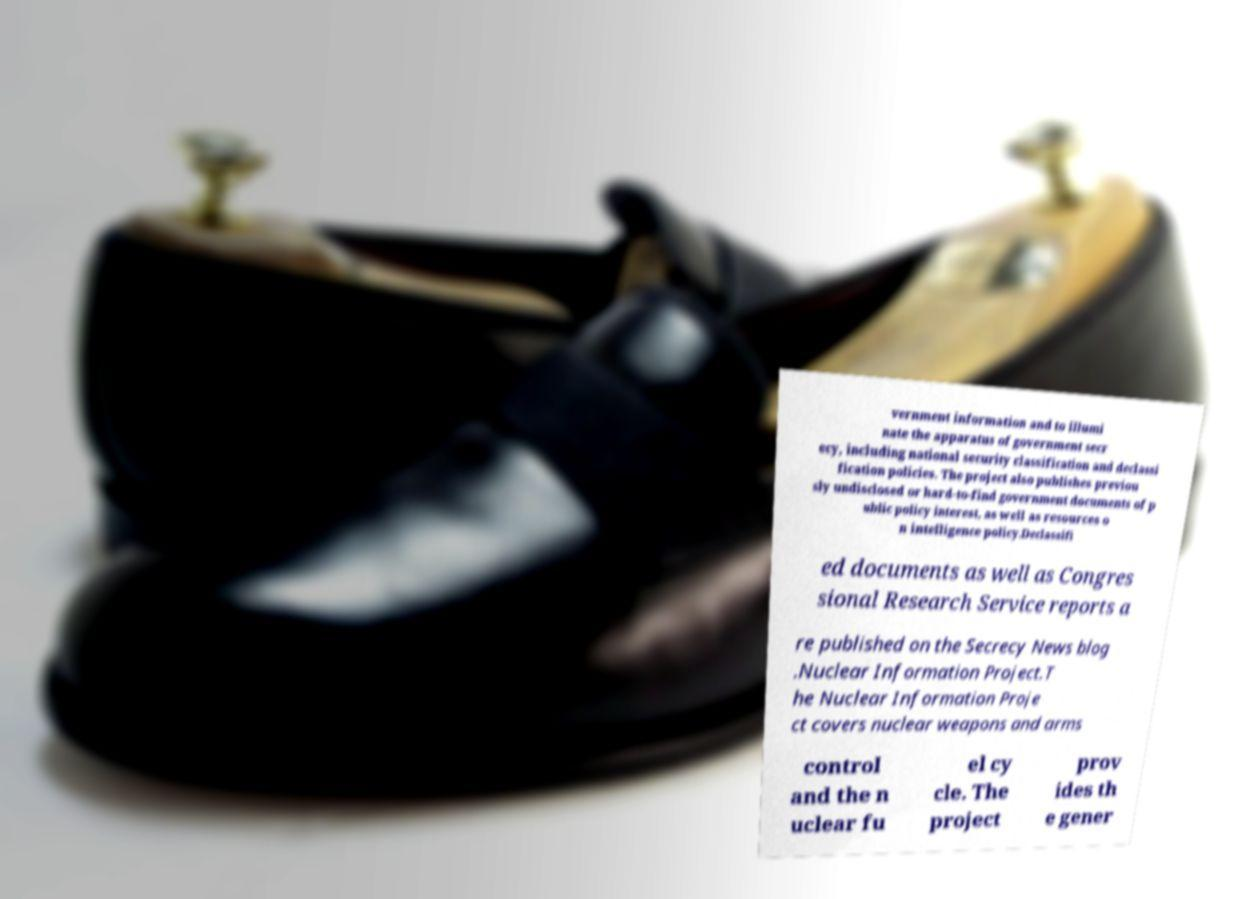What messages or text are displayed in this image? I need them in a readable, typed format. vernment information and to illumi nate the apparatus of government secr ecy, including national security classification and declassi fication policies. The project also publishes previou sly undisclosed or hard-to-find government documents of p ublic policy interest, as well as resources o n intelligence policy.Declassifi ed documents as well as Congres sional Research Service reports a re published on the Secrecy News blog .Nuclear Information Project.T he Nuclear Information Proje ct covers nuclear weapons and arms control and the n uclear fu el cy cle. The project prov ides th e gener 